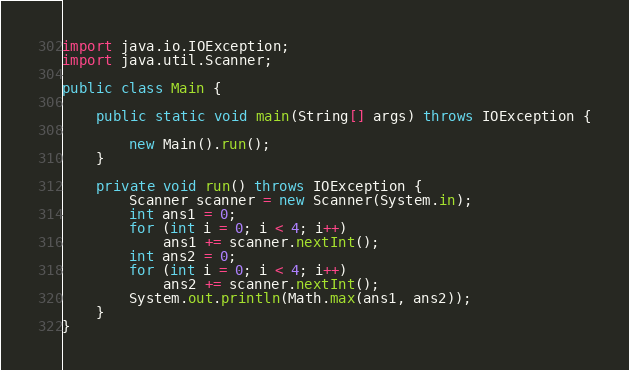<code> <loc_0><loc_0><loc_500><loc_500><_Java_>
import java.io.IOException;
import java.util.Scanner;

public class Main {

	public static void main(String[] args) throws IOException {

		new Main().run();
	}

	private void run() throws IOException {
		Scanner scanner = new Scanner(System.in);
		int ans1 = 0;
		for (int i = 0; i < 4; i++)
			ans1 += scanner.nextInt();
		int ans2 = 0;
		for (int i = 0; i < 4; i++)
			ans2 += scanner.nextInt();
		System.out.println(Math.max(ans1, ans2));
	}
}</code> 